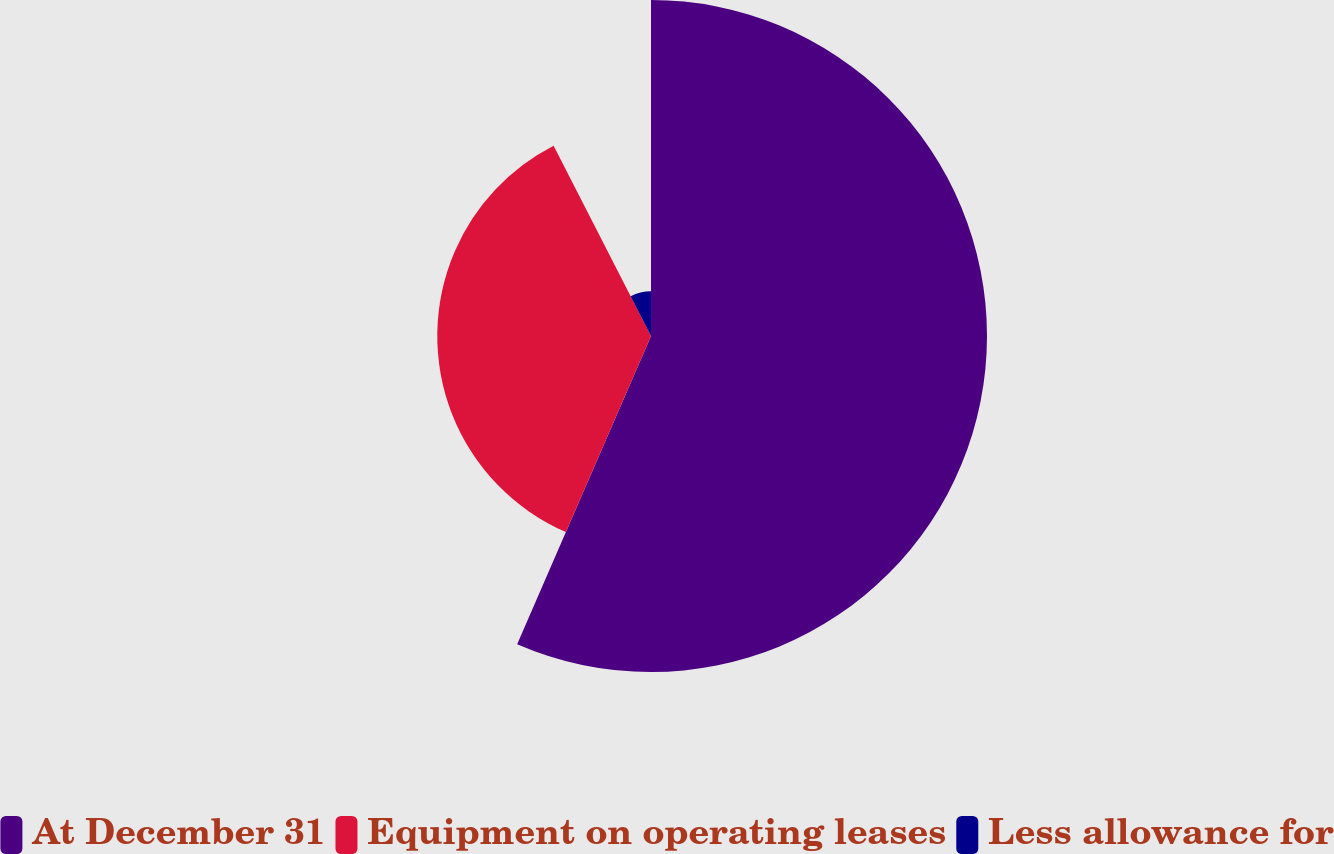Convert chart to OTSL. <chart><loc_0><loc_0><loc_500><loc_500><pie_chart><fcel>At December 31<fcel>Equipment on operating leases<fcel>Less allowance for<nl><fcel>56.52%<fcel>35.95%<fcel>7.53%<nl></chart> 